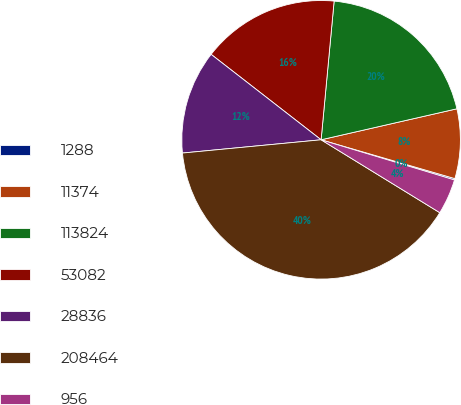Convert chart. <chart><loc_0><loc_0><loc_500><loc_500><pie_chart><fcel>1288<fcel>11374<fcel>113824<fcel>53082<fcel>28836<fcel>208464<fcel>956<nl><fcel>0.16%<fcel>8.07%<fcel>19.94%<fcel>15.98%<fcel>12.03%<fcel>39.72%<fcel>4.11%<nl></chart> 